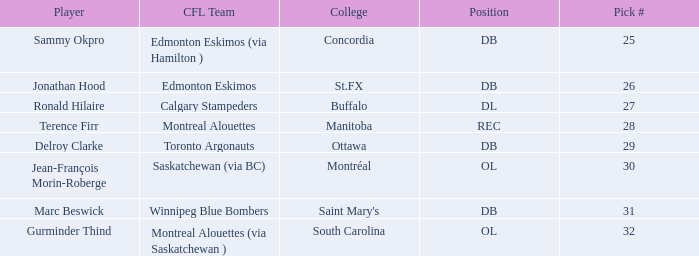What is the selection number of buffalo? 27.0. 